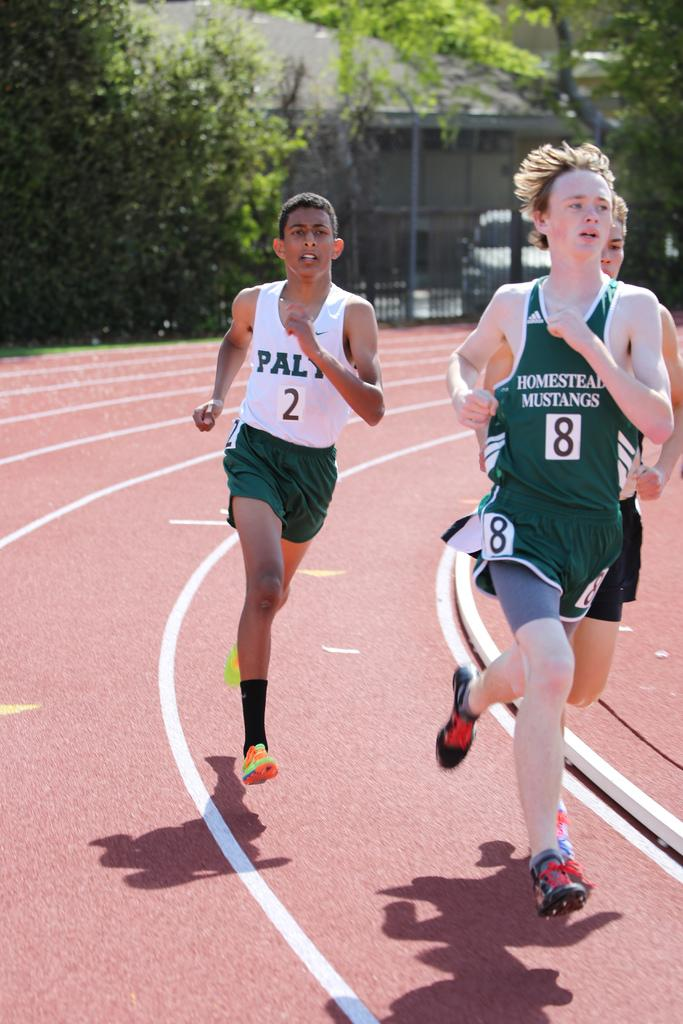<image>
Relay a brief, clear account of the picture shown. The man leading the race is wearing a mustangs shirt. 